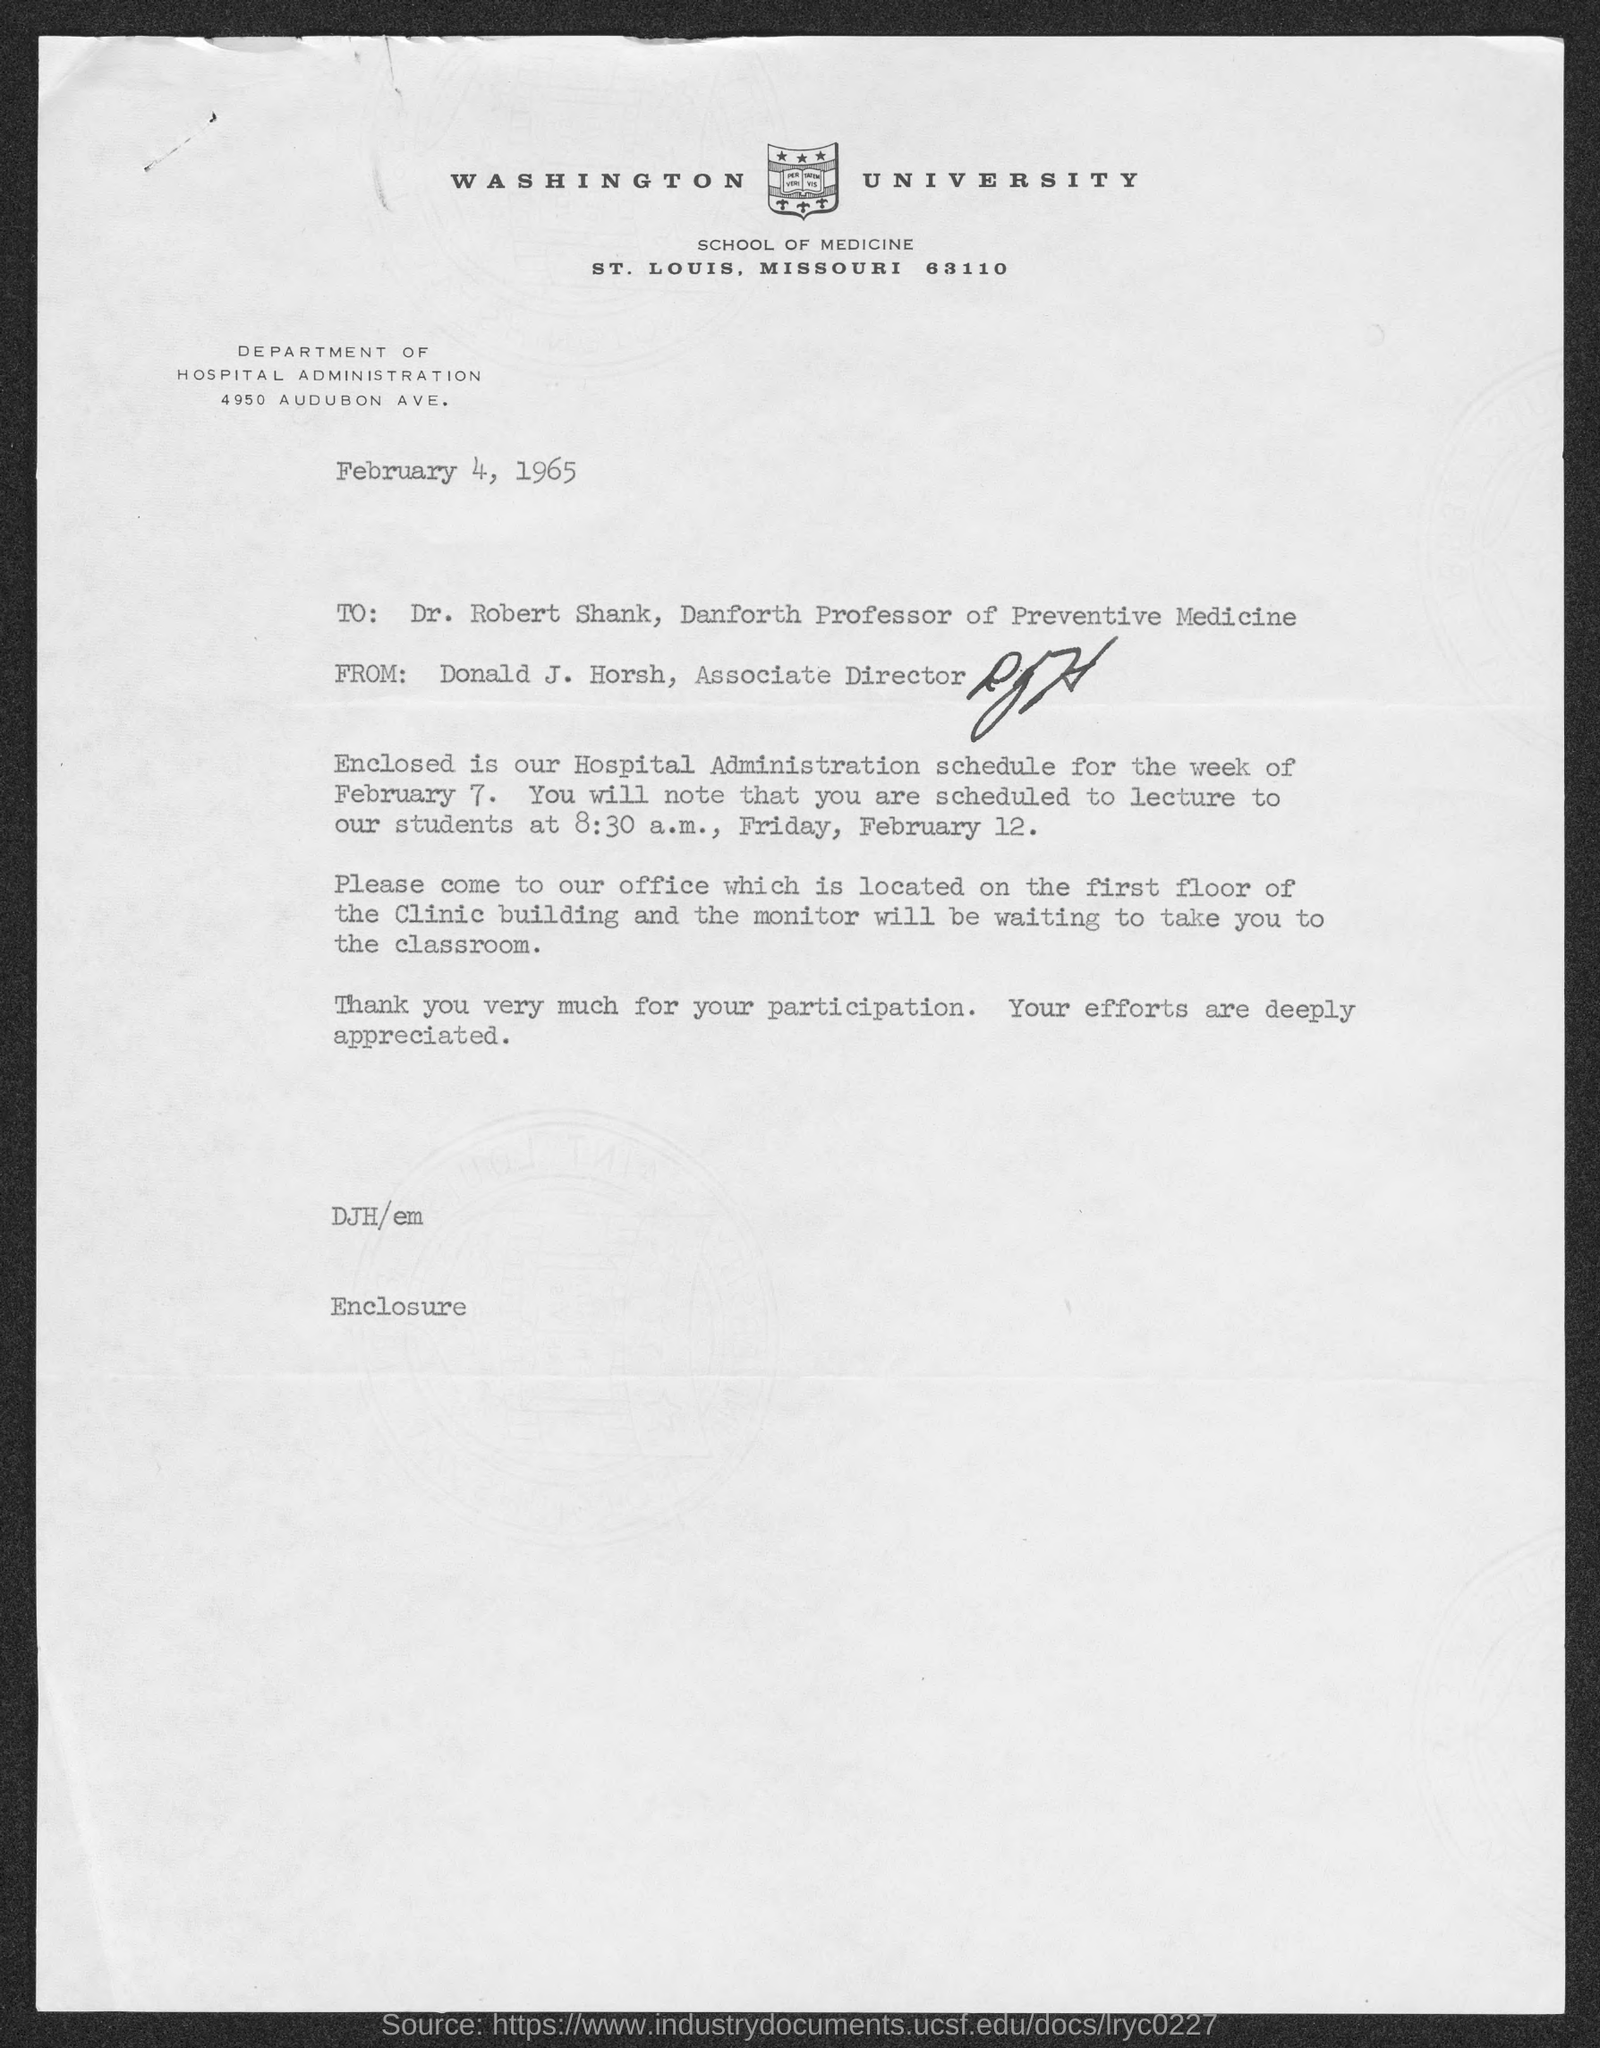When is the letter dated?
Your response must be concise. February 4, 1965. What is the street address of department of hospital administration ?
Keep it short and to the point. 4950 Audubon Ave. What is the position of dr. robert shank?
Make the answer very short. Professor of Preventive Medicine. What is the position of donald j. horsh ?
Keep it short and to the point. Associate Director. What is time scheduled for lecture on friday. february 12 ?
Provide a short and direct response. 8:30 a.m. What is the to address in letter?
Your response must be concise. Dr. Robert Shank. Who wrote this letter?
Offer a terse response. Donald J. Horsh, Associate DIrector. 